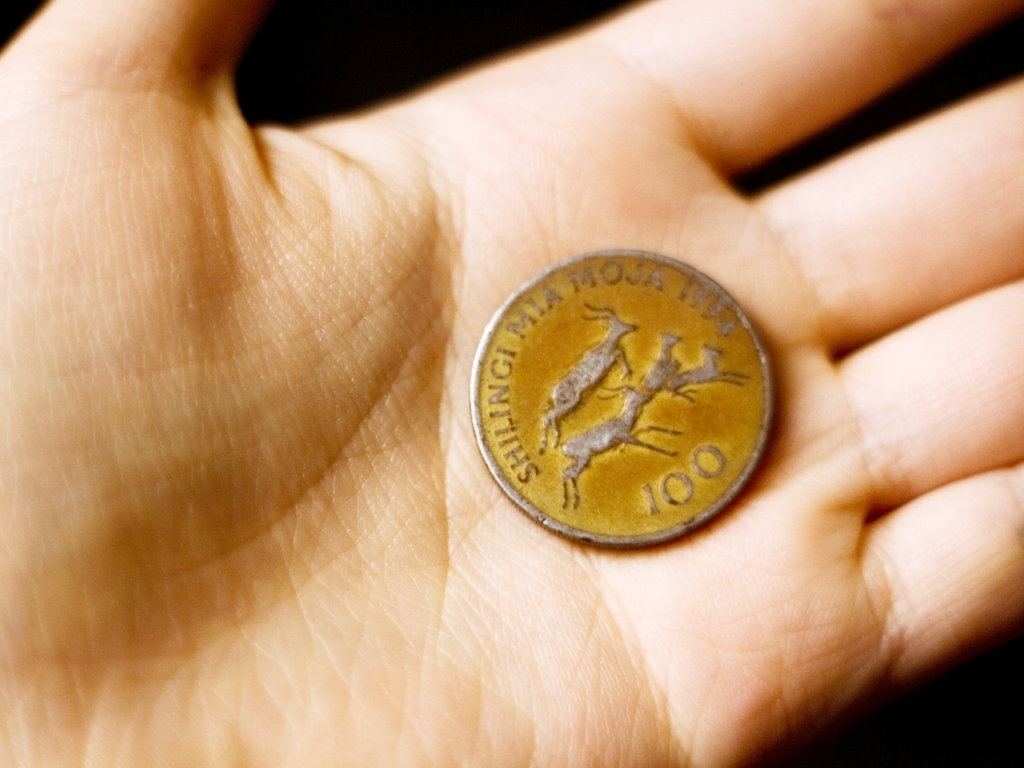How old does this coin look? Based on the patina and wear, it suggests the coin has seen some circulation, indicating it's not newly minted. Determining an exact age is difficult without knowledge of the specific coin series, but it carries characteristics of moderate age, possibly being several decades old. Based on its condition, what can this coin tell us about its usage over time? The coin's condition, with visible details yet signs of handling, implies it has been used in transactions but also reasonably well-preserved. This balance of use and care can reflect both the economic history in which it circulated and the habit of conserving coins as either collectibles or everyday currency. 